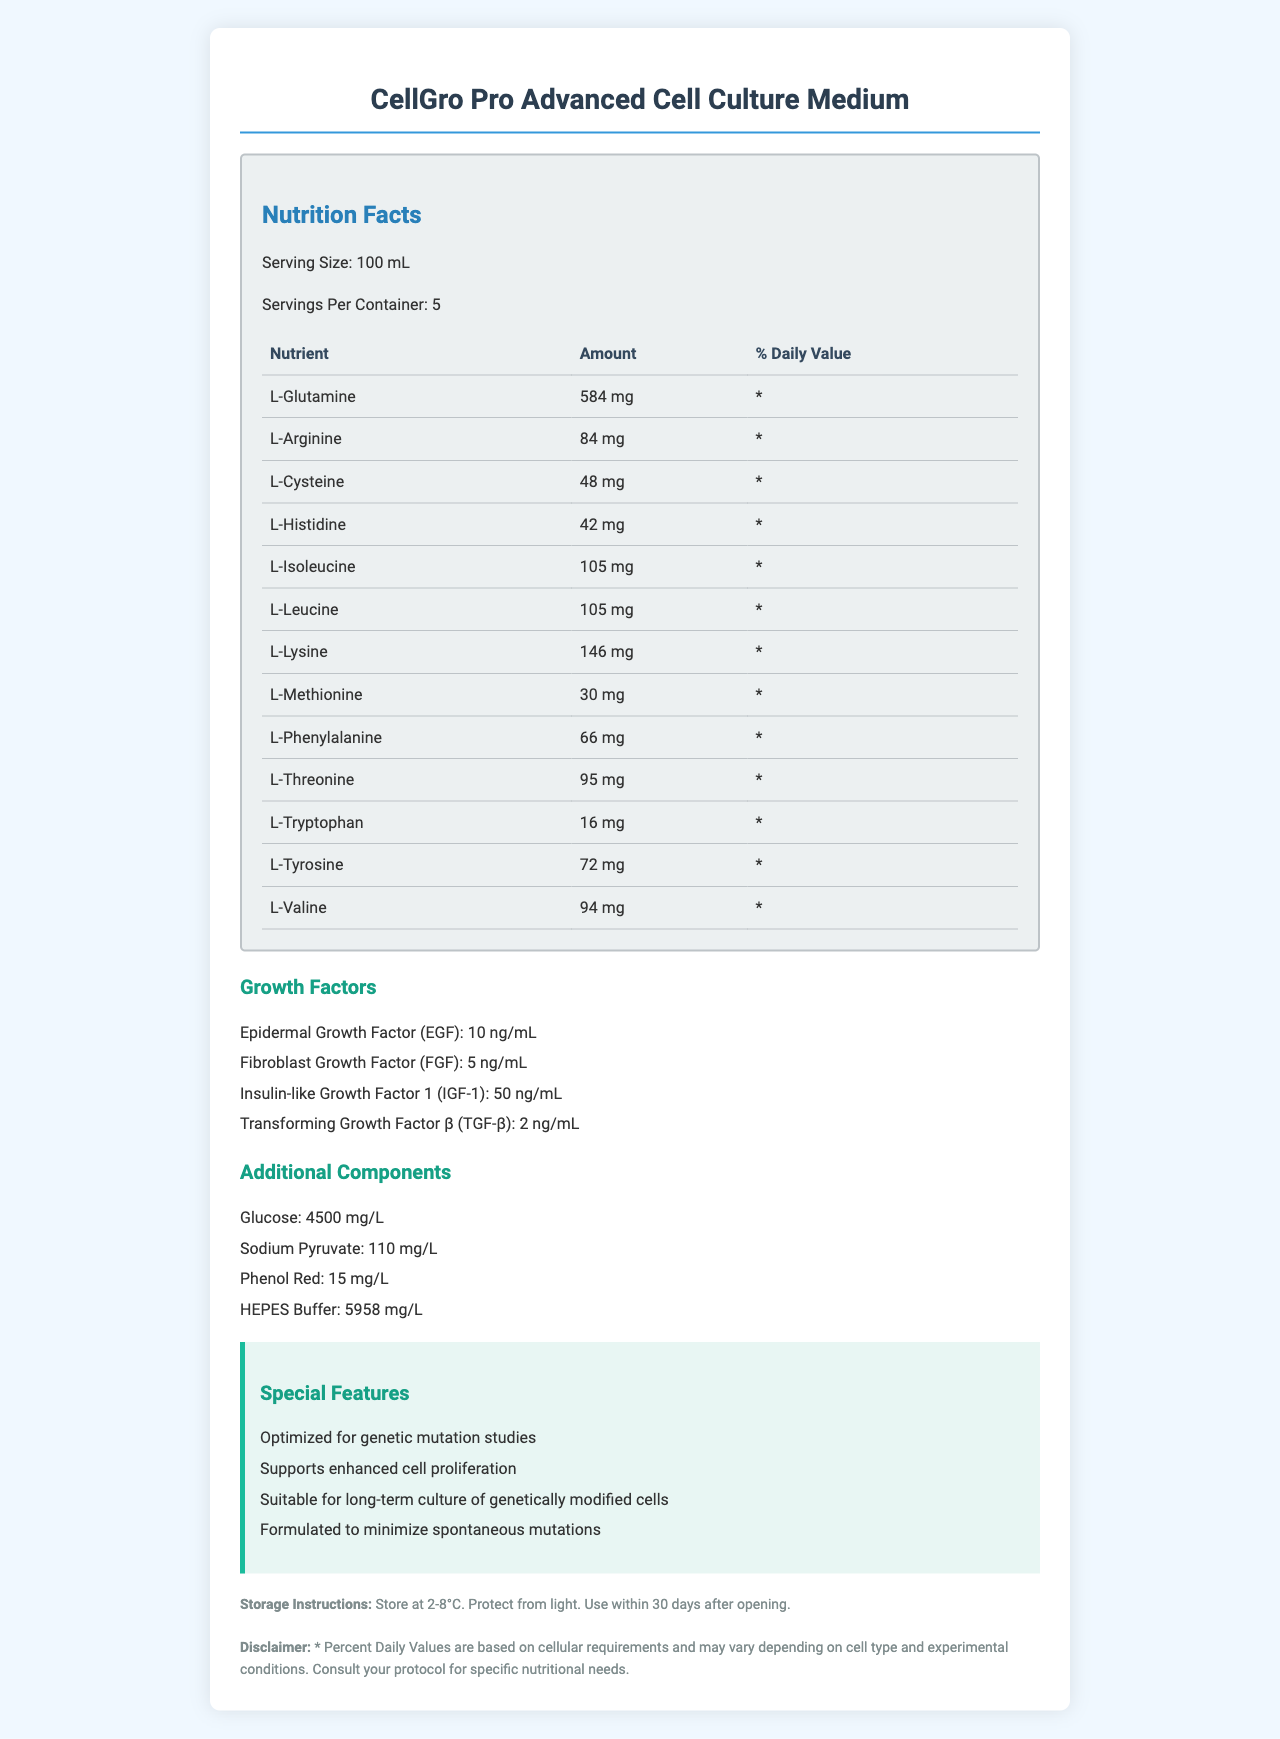what is the serving size of CellGro Pro Advanced Cell Culture Medium? The document specifies that the serving size is 100 mL in the Nutrition Facts section.
Answer: 100 mL how many servings per container are there? The document mentions that there are 5 servings per container.
Answer: 5 what is the amount of L-Glutamine per serving? The Nutrition Facts table lists L-Glutamine as having 584 mg per serving.
Answer: 584 mg which growth factor has the highest concentration? The document lists the concentration of IGF-1 as 50 ng/mL, which is higher than the other growth factors.
Answer: Insulin-like Growth Factor 1 (IGF-1) how many additional components are listed? The document lists Glucose, Sodium Pyruvate, Phenol Red, and HEPES Buffer as additional components.
Answer: 4 which of the following amino acids is present at the lowest concentration in the cell culture medium?
A. L-Tryptophan
B. L-Cysteine
C. L-Phenylalanine
D. L-Arginine L-Tryptophan is present at 16 mg, which is the lowest among the listed options.
Answer: A what are the special features of CellGro Pro Advanced Cell Culture Medium?
I. Optimized for genetic mutation studies
II. Supports spontaneous cell mutations
III. Suitable for short-term culture of genetically modified cells
IV. Minimizes spontaneous mutations The document lists that the medium is optimized for genetic mutation studies and formulated to minimize spontaneous mutations.
Answer: I, IV is this cell culture medium suitable for long-term culture of genetically modified cells? The document states that it is "suitable for long-term culture of genetically modified cells."
Answer: Yes summarize the main idea of the document. The document outlines the composition and benefits of the CellGro Pro Advanced Cell Culture Medium, highlighting its suitability for specialized genetic studies and long-term culture of genetically modified cells. It details nutritional content, additional components, storage instructions, and important disclaimers.
Answer: The document provides detailed nutrition facts, growth factors, and additional components of the CellGro Pro Advanced Cell Culture Medium. It emphasizes the special features of the product, including its optimized formulation for genetic mutation studies, enhanced cell proliferation, suitability for long-term culture of genetically modified cells, and minimization of spontaneous mutations. It also includes storage instructions and a disclaimer. what is the main use of Phenol Red in the cell culture medium? The document lists Phenol Red as an additional component but does not explicitly state its use.
Answer: Not enough information 